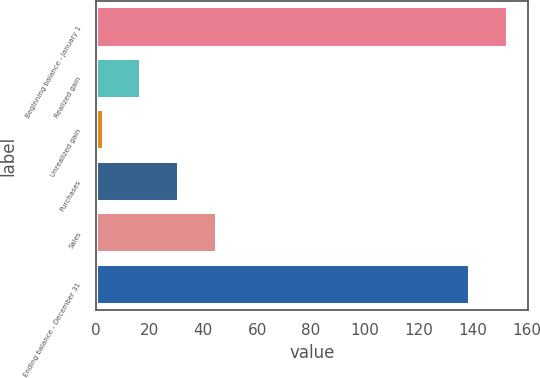Convert chart to OTSL. <chart><loc_0><loc_0><loc_500><loc_500><bar_chart><fcel>Beginning balance - January 1<fcel>Realized gain<fcel>Unrealized gain<fcel>Purchases<fcel>Sales<fcel>Ending balance - December 31<nl><fcel>153<fcel>17<fcel>3<fcel>31<fcel>45<fcel>139<nl></chart> 